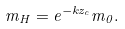Convert formula to latex. <formula><loc_0><loc_0><loc_500><loc_500>m _ { H } = e ^ { - k z _ { c } } m _ { 0 } .</formula> 